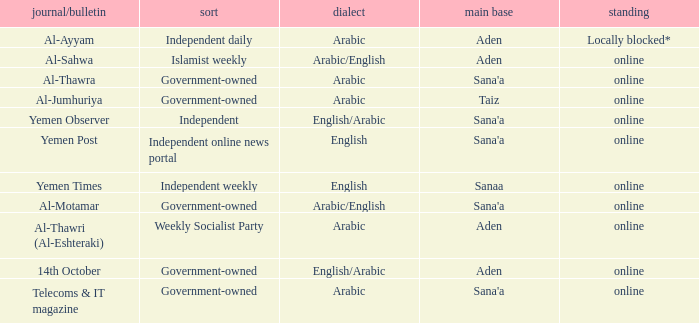What is Headquarter, when Type is Government-Owned, and when Newspaper/Magazine is Al-Jumhuriya? Taiz. Give me the full table as a dictionary. {'header': ['journal/bulletin', 'sort', 'dialect', 'main base', 'standing'], 'rows': [['Al-Ayyam', 'Independent daily', 'Arabic', 'Aden', 'Locally blocked*'], ['Al-Sahwa', 'Islamist weekly', 'Arabic/English', 'Aden', 'online'], ['Al-Thawra', 'Government-owned', 'Arabic', "Sana'a", 'online'], ['Al-Jumhuriya', 'Government-owned', 'Arabic', 'Taiz', 'online'], ['Yemen Observer', 'Independent', 'English/Arabic', "Sana'a", 'online'], ['Yemen Post', 'Independent online news portal', 'English', "Sana'a", 'online'], ['Yemen Times', 'Independent weekly', 'English', 'Sanaa', 'online'], ['Al-Motamar', 'Government-owned', 'Arabic/English', "Sana'a", 'online'], ['Al-Thawri (Al-Eshteraki)', 'Weekly Socialist Party', 'Arabic', 'Aden', 'online'], ['14th October', 'Government-owned', 'English/Arabic', 'Aden', 'online'], ['Telecoms & IT magazine', 'Government-owned', 'Arabic', "Sana'a", 'online']]} 